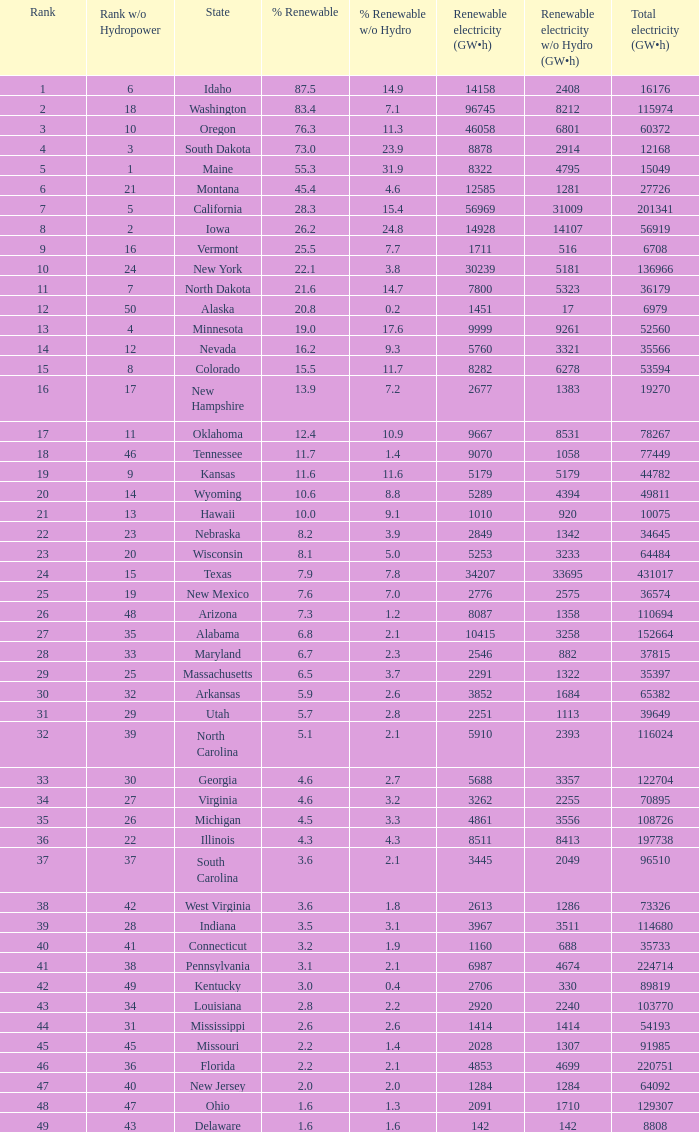When green electricity reaches 5760 (gw×h), what is the smallest amount of sustainable electricity without hydrogen energy? 3321.0. 